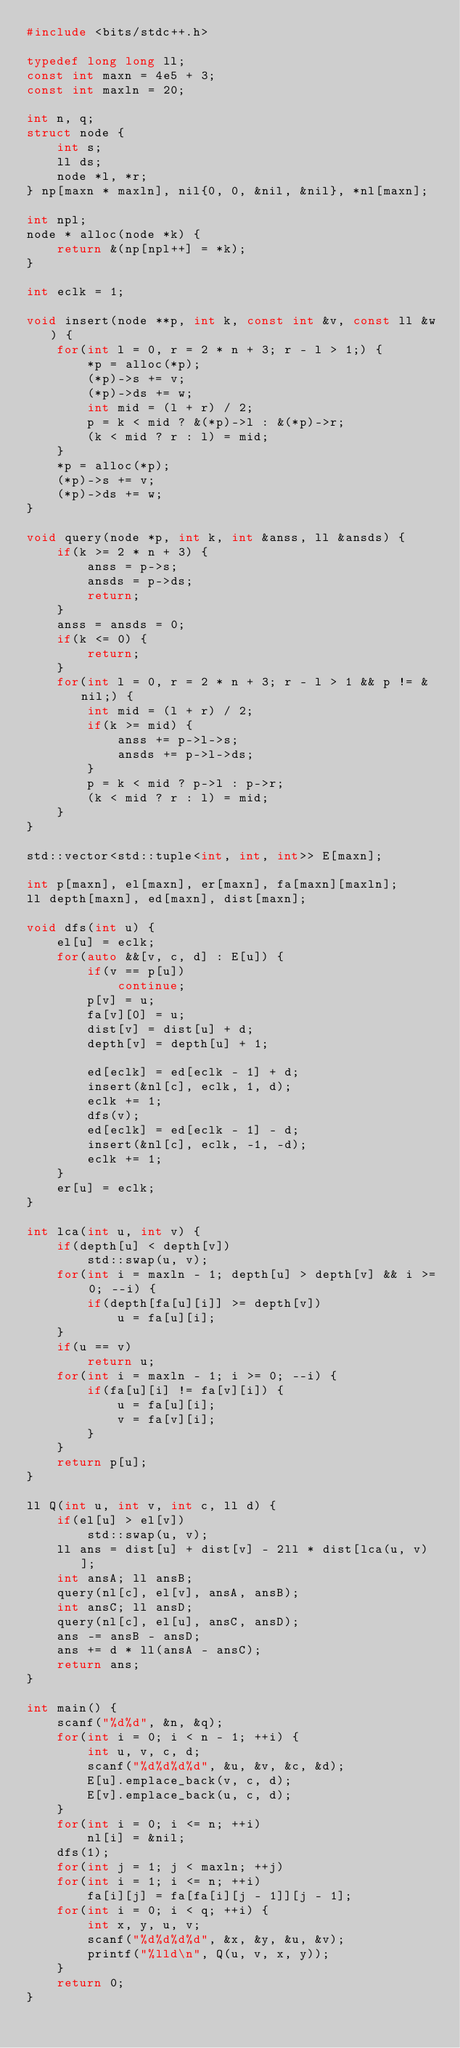<code> <loc_0><loc_0><loc_500><loc_500><_C++_>#include <bits/stdc++.h>

typedef long long ll;
const int maxn = 4e5 + 3;
const int maxln = 20;

int n, q;
struct node {
    int s;
    ll ds;
    node *l, *r;
} np[maxn * maxln], nil{0, 0, &nil, &nil}, *nl[maxn];

int npl;
node * alloc(node *k) {
    return &(np[npl++] = *k);
}

int eclk = 1;

void insert(node **p, int k, const int &v, const ll &w) {
    for(int l = 0, r = 2 * n + 3; r - l > 1;) {
        *p = alloc(*p);
        (*p)->s += v;
        (*p)->ds += w;
        int mid = (l + r) / 2;
        p = k < mid ? &(*p)->l : &(*p)->r;
        (k < mid ? r : l) = mid;
    }
    *p = alloc(*p);
    (*p)->s += v;
    (*p)->ds += w;
}

void query(node *p, int k, int &anss, ll &ansds) {
    if(k >= 2 * n + 3) {
        anss = p->s;
        ansds = p->ds;
        return;
    }
    anss = ansds = 0;
    if(k <= 0) {
        return;
    }
    for(int l = 0, r = 2 * n + 3; r - l > 1 && p != &nil;) {
        int mid = (l + r) / 2;
        if(k >= mid) {
            anss += p->l->s;
            ansds += p->l->ds;
        }
        p = k < mid ? p->l : p->r;
        (k < mid ? r : l) = mid;
    }
}

std::vector<std::tuple<int, int, int>> E[maxn];

int p[maxn], el[maxn], er[maxn], fa[maxn][maxln];
ll depth[maxn], ed[maxn], dist[maxn];

void dfs(int u) {
    el[u] = eclk;
    for(auto &&[v, c, d] : E[u]) {
        if(v == p[u])
            continue;
        p[v] = u;
        fa[v][0] = u;
        dist[v] = dist[u] + d;
        depth[v] = depth[u] + 1;

        ed[eclk] = ed[eclk - 1] + d;
        insert(&nl[c], eclk, 1, d);
        eclk += 1;
        dfs(v);
        ed[eclk] = ed[eclk - 1] - d;
        insert(&nl[c], eclk, -1, -d);
        eclk += 1;
    }
    er[u] = eclk;
}

int lca(int u, int v) {
    if(depth[u] < depth[v])
        std::swap(u, v);
    for(int i = maxln - 1; depth[u] > depth[v] && i >= 0; --i) {
        if(depth[fa[u][i]] >= depth[v])
            u = fa[u][i];
    }
    if(u == v)
        return u;
    for(int i = maxln - 1; i >= 0; --i) {
        if(fa[u][i] != fa[v][i]) {
            u = fa[u][i];
            v = fa[v][i];
        }
    }
    return p[u];
}

ll Q(int u, int v, int c, ll d) {
    if(el[u] > el[v])
        std::swap(u, v);
    ll ans = dist[u] + dist[v] - 2ll * dist[lca(u, v)];
    int ansA; ll ansB;
    query(nl[c], el[v], ansA, ansB);
    int ansC; ll ansD;
    query(nl[c], el[u], ansC, ansD);
    ans -= ansB - ansD;
    ans += d * ll(ansA - ansC);
    return ans;
}

int main() {
    scanf("%d%d", &n, &q);
    for(int i = 0; i < n - 1; ++i) {
        int u, v, c, d;
        scanf("%d%d%d%d", &u, &v, &c, &d);
        E[u].emplace_back(v, c, d);
        E[v].emplace_back(u, c, d);
    }
    for(int i = 0; i <= n; ++i)
        nl[i] = &nil;
    dfs(1);
    for(int j = 1; j < maxln; ++j)
    for(int i = 1; i <= n; ++i)
        fa[i][j] = fa[fa[i][j - 1]][j - 1];
    for(int i = 0; i < q; ++i) {
        int x, y, u, v;
        scanf("%d%d%d%d", &x, &y, &u, &v);
        printf("%lld\n", Q(u, v, x, y));
    }
    return 0;
}</code> 